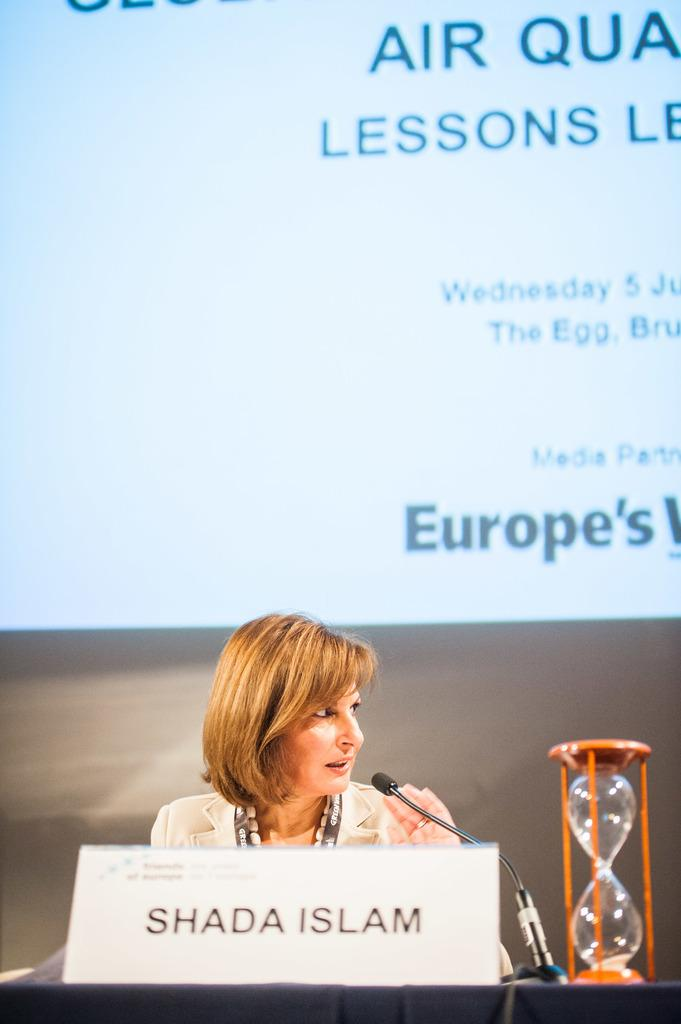Who is the main subject in the image? There is a lady in the image. Where is the lady positioned in the image? The lady is sitting in the center of the image. What objects are in front of the lady? There is a name plate, a mic, and a sand timer in front of the lady. What might be in the background of the image? It appears there is a projector screen in the background. What type of advertisement is being displayed on the projector screen in the image? There is no advertisement visible on the projector screen in the image. How many ducks are present in the image? There are no ducks present in the image. 